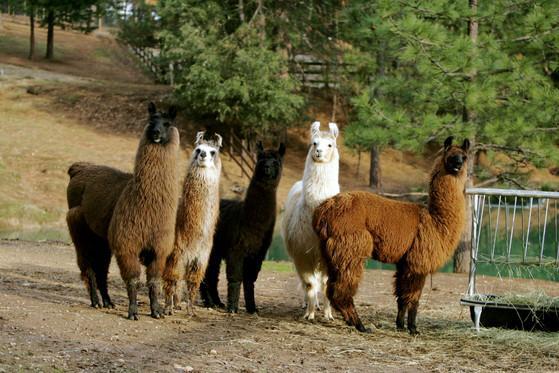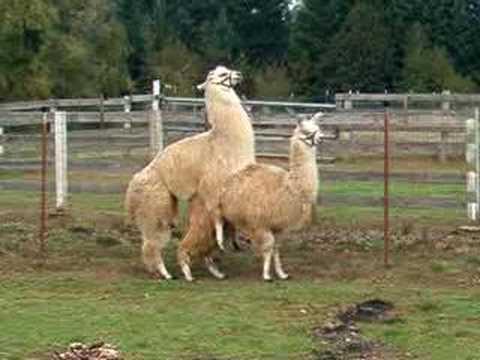The first image is the image on the left, the second image is the image on the right. Given the left and right images, does the statement "Each image shows a pair of llamas in the foreground, and at least one pair includes a white llama and a brownish llama." hold true? Answer yes or no. No. The first image is the image on the left, the second image is the image on the right. Given the left and right images, does the statement "The animals in the image on the right are surrounding by a fence." hold true? Answer yes or no. Yes. 